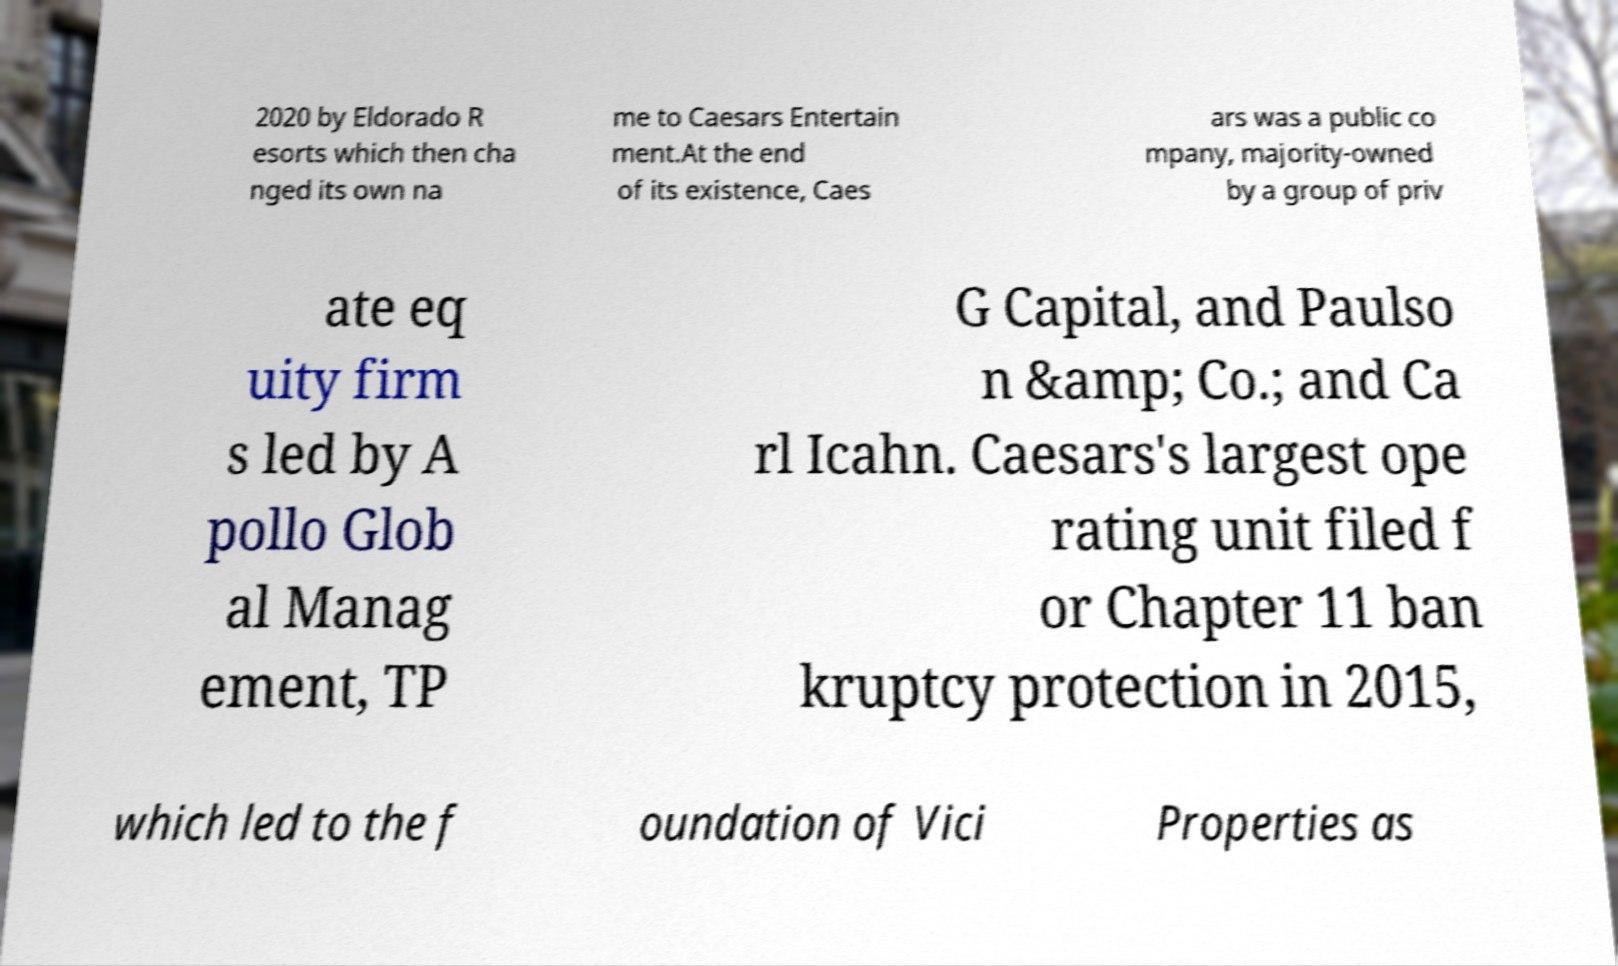Can you read and provide the text displayed in the image?This photo seems to have some interesting text. Can you extract and type it out for me? 2020 by Eldorado R esorts which then cha nged its own na me to Caesars Entertain ment.At the end of its existence, Caes ars was a public co mpany, majority-owned by a group of priv ate eq uity firm s led by A pollo Glob al Manag ement, TP G Capital, and Paulso n &amp; Co.; and Ca rl Icahn. Caesars's largest ope rating unit filed f or Chapter 11 ban kruptcy protection in 2015, which led to the f oundation of Vici Properties as 